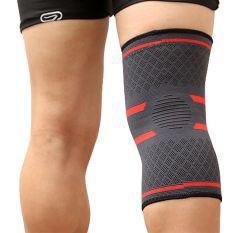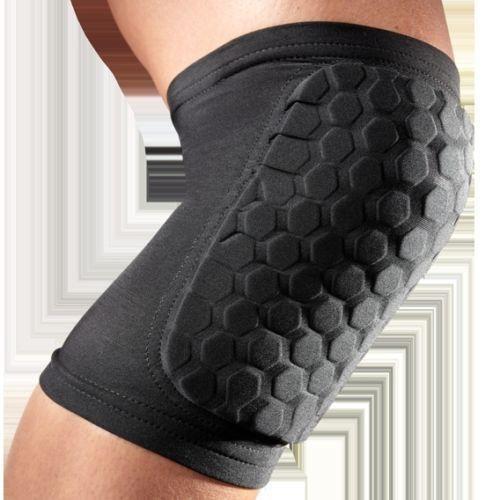The first image is the image on the left, the second image is the image on the right. Analyze the images presented: Is the assertion "An image shows a pair of legs with one one leg wearing a knee wrap." valid? Answer yes or no. Yes. The first image is the image on the left, the second image is the image on the right. Examine the images to the left and right. Is the description "The left image is one black brace, the right image is one white brace." accurate? Answer yes or no. No. 